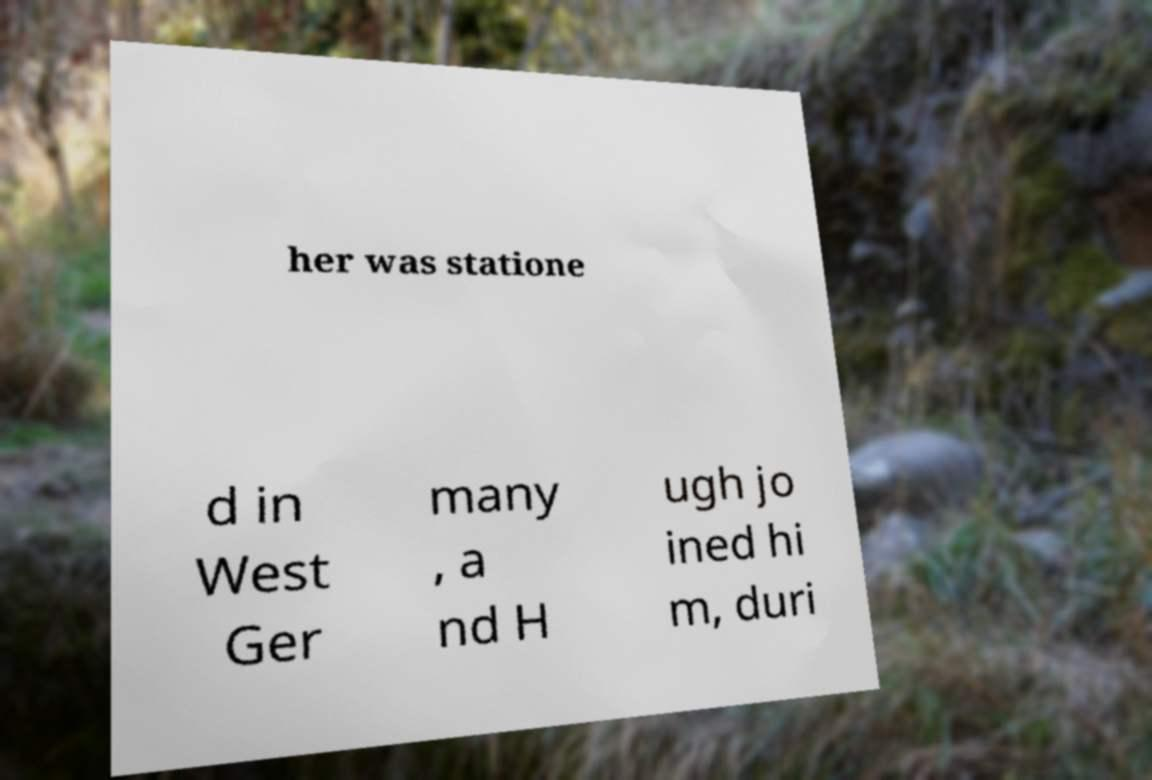Could you assist in decoding the text presented in this image and type it out clearly? her was statione d in West Ger many , a nd H ugh jo ined hi m, duri 